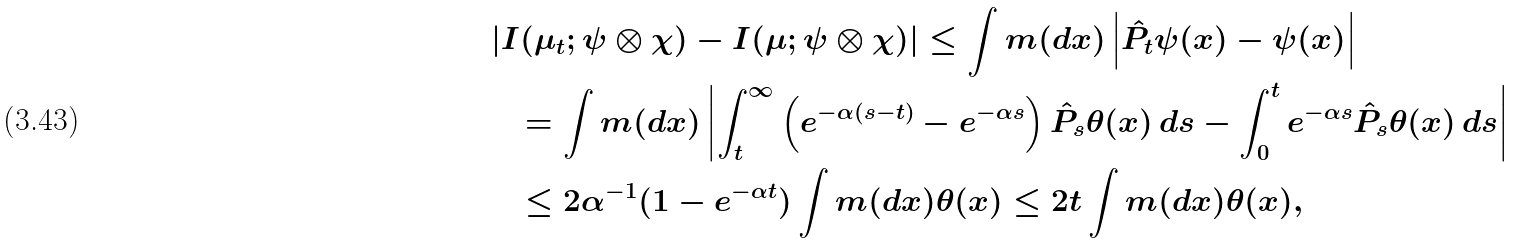<formula> <loc_0><loc_0><loc_500><loc_500>& \left | I ( \mu _ { t } ; \psi \otimes \chi ) - I ( \mu ; \psi \otimes \chi ) \right | \leq \int m ( d x ) \left | \hat { P } _ { t } \psi ( x ) - \psi ( x ) \right | \\ & \quad = \int m ( d x ) \left | \int _ { t } ^ { \infty } \left ( e ^ { - \alpha ( s - t ) } - e ^ { - \alpha s } \right ) \hat { P } _ { s } \theta ( x ) \, d s - \int _ { 0 } ^ { t } e ^ { - \alpha s } \hat { P } _ { s } \theta ( x ) \, d s \right | \\ & \quad \leq 2 \alpha ^ { - 1 } ( 1 - e ^ { - \alpha t } ) \int m ( d x ) \theta ( x ) \leq 2 t \int m ( d x ) \theta ( x ) , \\</formula> 